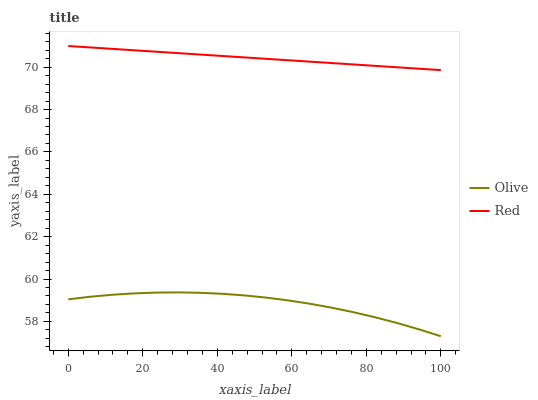Does Olive have the minimum area under the curve?
Answer yes or no. Yes. Does Red have the maximum area under the curve?
Answer yes or no. Yes. Does Red have the minimum area under the curve?
Answer yes or no. No. Is Red the smoothest?
Answer yes or no. Yes. Is Olive the roughest?
Answer yes or no. Yes. Is Red the roughest?
Answer yes or no. No. Does Olive have the lowest value?
Answer yes or no. Yes. Does Red have the lowest value?
Answer yes or no. No. Does Red have the highest value?
Answer yes or no. Yes. Is Olive less than Red?
Answer yes or no. Yes. Is Red greater than Olive?
Answer yes or no. Yes. Does Olive intersect Red?
Answer yes or no. No. 